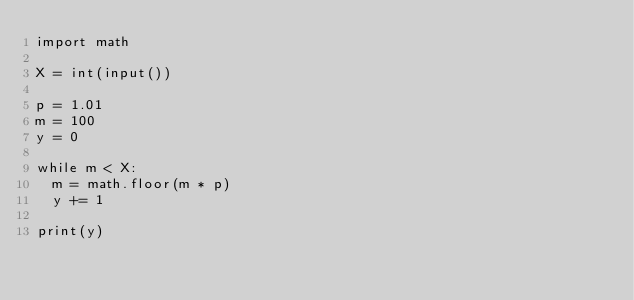<code> <loc_0><loc_0><loc_500><loc_500><_Python_>import math

X = int(input())

p = 1.01
m = 100
y = 0

while m < X:
  m = math.floor(m * p)
  y += 1

print(y)</code> 